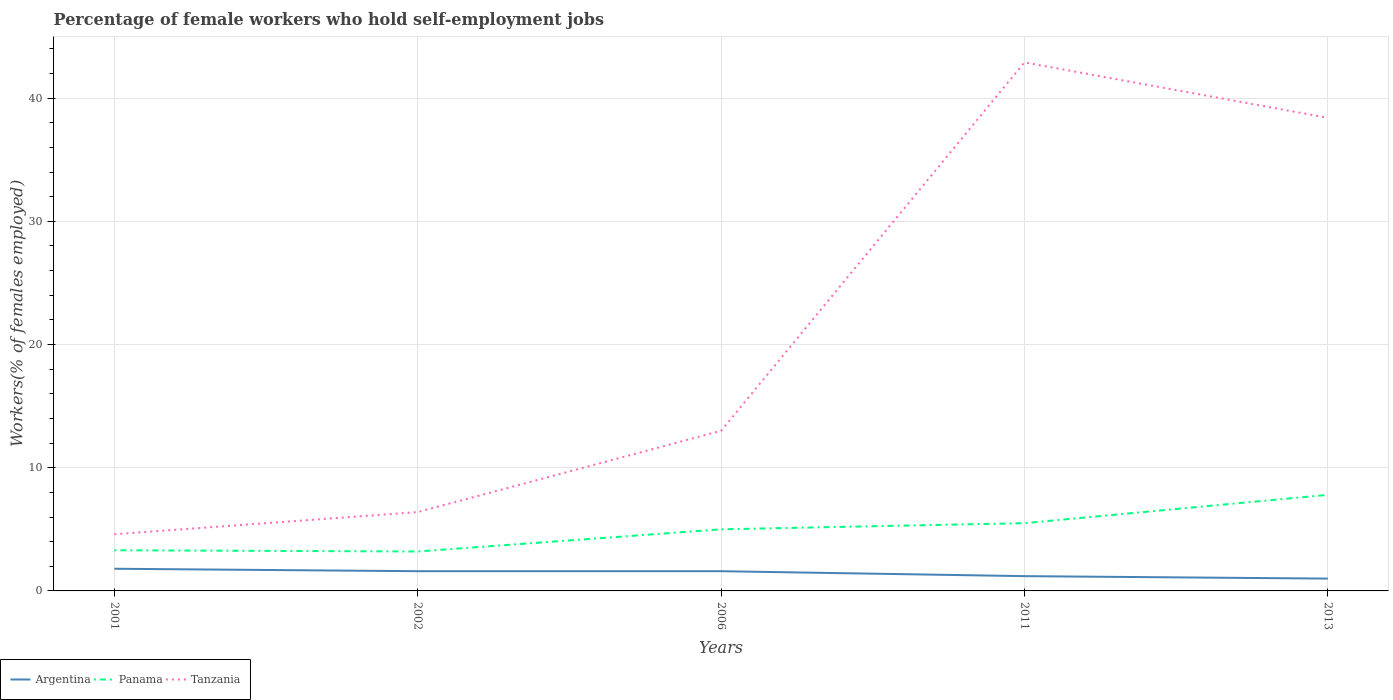How many different coloured lines are there?
Give a very brief answer. 3. Does the line corresponding to Argentina intersect with the line corresponding to Tanzania?
Offer a very short reply. No. Across all years, what is the maximum percentage of self-employed female workers in Tanzania?
Provide a short and direct response. 4.6. In which year was the percentage of self-employed female workers in Tanzania maximum?
Offer a terse response. 2001. What is the total percentage of self-employed female workers in Tanzania in the graph?
Offer a very short reply. -8.4. What is the difference between the highest and the second highest percentage of self-employed female workers in Tanzania?
Provide a short and direct response. 38.3. What is the difference between the highest and the lowest percentage of self-employed female workers in Panama?
Make the answer very short. 3. What is the difference between two consecutive major ticks on the Y-axis?
Give a very brief answer. 10. Are the values on the major ticks of Y-axis written in scientific E-notation?
Your response must be concise. No. Where does the legend appear in the graph?
Ensure brevity in your answer.  Bottom left. How many legend labels are there?
Offer a terse response. 3. How are the legend labels stacked?
Provide a succinct answer. Horizontal. What is the title of the graph?
Provide a short and direct response. Percentage of female workers who hold self-employment jobs. What is the label or title of the X-axis?
Ensure brevity in your answer.  Years. What is the label or title of the Y-axis?
Your answer should be very brief. Workers(% of females employed). What is the Workers(% of females employed) of Argentina in 2001?
Your response must be concise. 1.8. What is the Workers(% of females employed) in Panama in 2001?
Give a very brief answer. 3.3. What is the Workers(% of females employed) of Tanzania in 2001?
Offer a terse response. 4.6. What is the Workers(% of females employed) in Argentina in 2002?
Provide a succinct answer. 1.6. What is the Workers(% of females employed) of Panama in 2002?
Your response must be concise. 3.2. What is the Workers(% of females employed) in Tanzania in 2002?
Give a very brief answer. 6.4. What is the Workers(% of females employed) of Argentina in 2006?
Keep it short and to the point. 1.6. What is the Workers(% of females employed) in Tanzania in 2006?
Your response must be concise. 13. What is the Workers(% of females employed) in Argentina in 2011?
Offer a very short reply. 1.2. What is the Workers(% of females employed) of Tanzania in 2011?
Offer a terse response. 42.9. What is the Workers(% of females employed) of Argentina in 2013?
Keep it short and to the point. 1. What is the Workers(% of females employed) in Panama in 2013?
Your answer should be compact. 7.8. What is the Workers(% of females employed) in Tanzania in 2013?
Provide a short and direct response. 38.4. Across all years, what is the maximum Workers(% of females employed) of Argentina?
Ensure brevity in your answer.  1.8. Across all years, what is the maximum Workers(% of females employed) of Panama?
Offer a very short reply. 7.8. Across all years, what is the maximum Workers(% of females employed) of Tanzania?
Keep it short and to the point. 42.9. Across all years, what is the minimum Workers(% of females employed) of Panama?
Your answer should be compact. 3.2. Across all years, what is the minimum Workers(% of females employed) in Tanzania?
Your response must be concise. 4.6. What is the total Workers(% of females employed) in Argentina in the graph?
Offer a terse response. 7.2. What is the total Workers(% of females employed) in Panama in the graph?
Keep it short and to the point. 24.8. What is the total Workers(% of females employed) in Tanzania in the graph?
Ensure brevity in your answer.  105.3. What is the difference between the Workers(% of females employed) in Argentina in 2001 and that in 2002?
Your response must be concise. 0.2. What is the difference between the Workers(% of females employed) in Panama in 2001 and that in 2002?
Provide a short and direct response. 0.1. What is the difference between the Workers(% of females employed) in Argentina in 2001 and that in 2006?
Offer a terse response. 0.2. What is the difference between the Workers(% of females employed) of Argentina in 2001 and that in 2011?
Provide a short and direct response. 0.6. What is the difference between the Workers(% of females employed) in Tanzania in 2001 and that in 2011?
Offer a very short reply. -38.3. What is the difference between the Workers(% of females employed) in Argentina in 2001 and that in 2013?
Offer a very short reply. 0.8. What is the difference between the Workers(% of females employed) of Tanzania in 2001 and that in 2013?
Ensure brevity in your answer.  -33.8. What is the difference between the Workers(% of females employed) in Argentina in 2002 and that in 2006?
Your answer should be compact. 0. What is the difference between the Workers(% of females employed) in Panama in 2002 and that in 2006?
Keep it short and to the point. -1.8. What is the difference between the Workers(% of females employed) in Tanzania in 2002 and that in 2011?
Offer a terse response. -36.5. What is the difference between the Workers(% of females employed) in Tanzania in 2002 and that in 2013?
Your answer should be very brief. -32. What is the difference between the Workers(% of females employed) in Argentina in 2006 and that in 2011?
Offer a very short reply. 0.4. What is the difference between the Workers(% of females employed) in Panama in 2006 and that in 2011?
Your response must be concise. -0.5. What is the difference between the Workers(% of females employed) of Tanzania in 2006 and that in 2011?
Your response must be concise. -29.9. What is the difference between the Workers(% of females employed) of Panama in 2006 and that in 2013?
Your answer should be very brief. -2.8. What is the difference between the Workers(% of females employed) of Tanzania in 2006 and that in 2013?
Make the answer very short. -25.4. What is the difference between the Workers(% of females employed) of Panama in 2011 and that in 2013?
Ensure brevity in your answer.  -2.3. What is the difference between the Workers(% of females employed) of Tanzania in 2011 and that in 2013?
Provide a succinct answer. 4.5. What is the difference between the Workers(% of females employed) in Argentina in 2001 and the Workers(% of females employed) in Panama in 2002?
Your answer should be compact. -1.4. What is the difference between the Workers(% of females employed) in Panama in 2001 and the Workers(% of females employed) in Tanzania in 2002?
Your answer should be very brief. -3.1. What is the difference between the Workers(% of females employed) in Argentina in 2001 and the Workers(% of females employed) in Tanzania in 2006?
Keep it short and to the point. -11.2. What is the difference between the Workers(% of females employed) of Argentina in 2001 and the Workers(% of females employed) of Tanzania in 2011?
Give a very brief answer. -41.1. What is the difference between the Workers(% of females employed) in Panama in 2001 and the Workers(% of females employed) in Tanzania in 2011?
Offer a very short reply. -39.6. What is the difference between the Workers(% of females employed) of Argentina in 2001 and the Workers(% of females employed) of Panama in 2013?
Make the answer very short. -6. What is the difference between the Workers(% of females employed) of Argentina in 2001 and the Workers(% of females employed) of Tanzania in 2013?
Make the answer very short. -36.6. What is the difference between the Workers(% of females employed) in Panama in 2001 and the Workers(% of females employed) in Tanzania in 2013?
Your response must be concise. -35.1. What is the difference between the Workers(% of females employed) in Panama in 2002 and the Workers(% of females employed) in Tanzania in 2006?
Your answer should be compact. -9.8. What is the difference between the Workers(% of females employed) in Argentina in 2002 and the Workers(% of females employed) in Panama in 2011?
Your answer should be compact. -3.9. What is the difference between the Workers(% of females employed) in Argentina in 2002 and the Workers(% of females employed) in Tanzania in 2011?
Keep it short and to the point. -41.3. What is the difference between the Workers(% of females employed) of Panama in 2002 and the Workers(% of females employed) of Tanzania in 2011?
Offer a terse response. -39.7. What is the difference between the Workers(% of females employed) of Argentina in 2002 and the Workers(% of females employed) of Tanzania in 2013?
Ensure brevity in your answer.  -36.8. What is the difference between the Workers(% of females employed) of Panama in 2002 and the Workers(% of females employed) of Tanzania in 2013?
Make the answer very short. -35.2. What is the difference between the Workers(% of females employed) of Argentina in 2006 and the Workers(% of females employed) of Panama in 2011?
Make the answer very short. -3.9. What is the difference between the Workers(% of females employed) in Argentina in 2006 and the Workers(% of females employed) in Tanzania in 2011?
Make the answer very short. -41.3. What is the difference between the Workers(% of females employed) of Panama in 2006 and the Workers(% of females employed) of Tanzania in 2011?
Your answer should be compact. -37.9. What is the difference between the Workers(% of females employed) of Argentina in 2006 and the Workers(% of females employed) of Tanzania in 2013?
Your answer should be compact. -36.8. What is the difference between the Workers(% of females employed) in Panama in 2006 and the Workers(% of females employed) in Tanzania in 2013?
Provide a short and direct response. -33.4. What is the difference between the Workers(% of females employed) in Argentina in 2011 and the Workers(% of females employed) in Tanzania in 2013?
Give a very brief answer. -37.2. What is the difference between the Workers(% of females employed) in Panama in 2011 and the Workers(% of females employed) in Tanzania in 2013?
Offer a very short reply. -32.9. What is the average Workers(% of females employed) of Argentina per year?
Give a very brief answer. 1.44. What is the average Workers(% of females employed) in Panama per year?
Ensure brevity in your answer.  4.96. What is the average Workers(% of females employed) in Tanzania per year?
Make the answer very short. 21.06. In the year 2001, what is the difference between the Workers(% of females employed) of Argentina and Workers(% of females employed) of Panama?
Make the answer very short. -1.5. In the year 2002, what is the difference between the Workers(% of females employed) of Argentina and Workers(% of females employed) of Tanzania?
Your response must be concise. -4.8. In the year 2006, what is the difference between the Workers(% of females employed) of Argentina and Workers(% of females employed) of Panama?
Give a very brief answer. -3.4. In the year 2011, what is the difference between the Workers(% of females employed) in Argentina and Workers(% of females employed) in Panama?
Your answer should be very brief. -4.3. In the year 2011, what is the difference between the Workers(% of females employed) in Argentina and Workers(% of females employed) in Tanzania?
Your answer should be compact. -41.7. In the year 2011, what is the difference between the Workers(% of females employed) of Panama and Workers(% of females employed) of Tanzania?
Give a very brief answer. -37.4. In the year 2013, what is the difference between the Workers(% of females employed) in Argentina and Workers(% of females employed) in Panama?
Offer a terse response. -6.8. In the year 2013, what is the difference between the Workers(% of females employed) of Argentina and Workers(% of females employed) of Tanzania?
Offer a very short reply. -37.4. In the year 2013, what is the difference between the Workers(% of females employed) in Panama and Workers(% of females employed) in Tanzania?
Provide a short and direct response. -30.6. What is the ratio of the Workers(% of females employed) of Panama in 2001 to that in 2002?
Your answer should be very brief. 1.03. What is the ratio of the Workers(% of females employed) of Tanzania in 2001 to that in 2002?
Make the answer very short. 0.72. What is the ratio of the Workers(% of females employed) of Argentina in 2001 to that in 2006?
Your answer should be compact. 1.12. What is the ratio of the Workers(% of females employed) in Panama in 2001 to that in 2006?
Your answer should be very brief. 0.66. What is the ratio of the Workers(% of females employed) of Tanzania in 2001 to that in 2006?
Give a very brief answer. 0.35. What is the ratio of the Workers(% of females employed) in Argentina in 2001 to that in 2011?
Give a very brief answer. 1.5. What is the ratio of the Workers(% of females employed) of Tanzania in 2001 to that in 2011?
Offer a very short reply. 0.11. What is the ratio of the Workers(% of females employed) in Argentina in 2001 to that in 2013?
Provide a short and direct response. 1.8. What is the ratio of the Workers(% of females employed) in Panama in 2001 to that in 2013?
Make the answer very short. 0.42. What is the ratio of the Workers(% of females employed) in Tanzania in 2001 to that in 2013?
Keep it short and to the point. 0.12. What is the ratio of the Workers(% of females employed) in Argentina in 2002 to that in 2006?
Offer a very short reply. 1. What is the ratio of the Workers(% of females employed) of Panama in 2002 to that in 2006?
Provide a succinct answer. 0.64. What is the ratio of the Workers(% of females employed) in Tanzania in 2002 to that in 2006?
Offer a terse response. 0.49. What is the ratio of the Workers(% of females employed) in Argentina in 2002 to that in 2011?
Make the answer very short. 1.33. What is the ratio of the Workers(% of females employed) of Panama in 2002 to that in 2011?
Provide a succinct answer. 0.58. What is the ratio of the Workers(% of females employed) in Tanzania in 2002 to that in 2011?
Provide a short and direct response. 0.15. What is the ratio of the Workers(% of females employed) of Argentina in 2002 to that in 2013?
Offer a terse response. 1.6. What is the ratio of the Workers(% of females employed) of Panama in 2002 to that in 2013?
Offer a very short reply. 0.41. What is the ratio of the Workers(% of females employed) of Panama in 2006 to that in 2011?
Make the answer very short. 0.91. What is the ratio of the Workers(% of females employed) of Tanzania in 2006 to that in 2011?
Ensure brevity in your answer.  0.3. What is the ratio of the Workers(% of females employed) in Argentina in 2006 to that in 2013?
Your answer should be very brief. 1.6. What is the ratio of the Workers(% of females employed) of Panama in 2006 to that in 2013?
Ensure brevity in your answer.  0.64. What is the ratio of the Workers(% of females employed) of Tanzania in 2006 to that in 2013?
Ensure brevity in your answer.  0.34. What is the ratio of the Workers(% of females employed) in Panama in 2011 to that in 2013?
Your answer should be compact. 0.71. What is the ratio of the Workers(% of females employed) in Tanzania in 2011 to that in 2013?
Your response must be concise. 1.12. What is the difference between the highest and the second highest Workers(% of females employed) of Argentina?
Provide a short and direct response. 0.2. What is the difference between the highest and the second highest Workers(% of females employed) in Panama?
Provide a short and direct response. 2.3. What is the difference between the highest and the lowest Workers(% of females employed) in Tanzania?
Your answer should be compact. 38.3. 